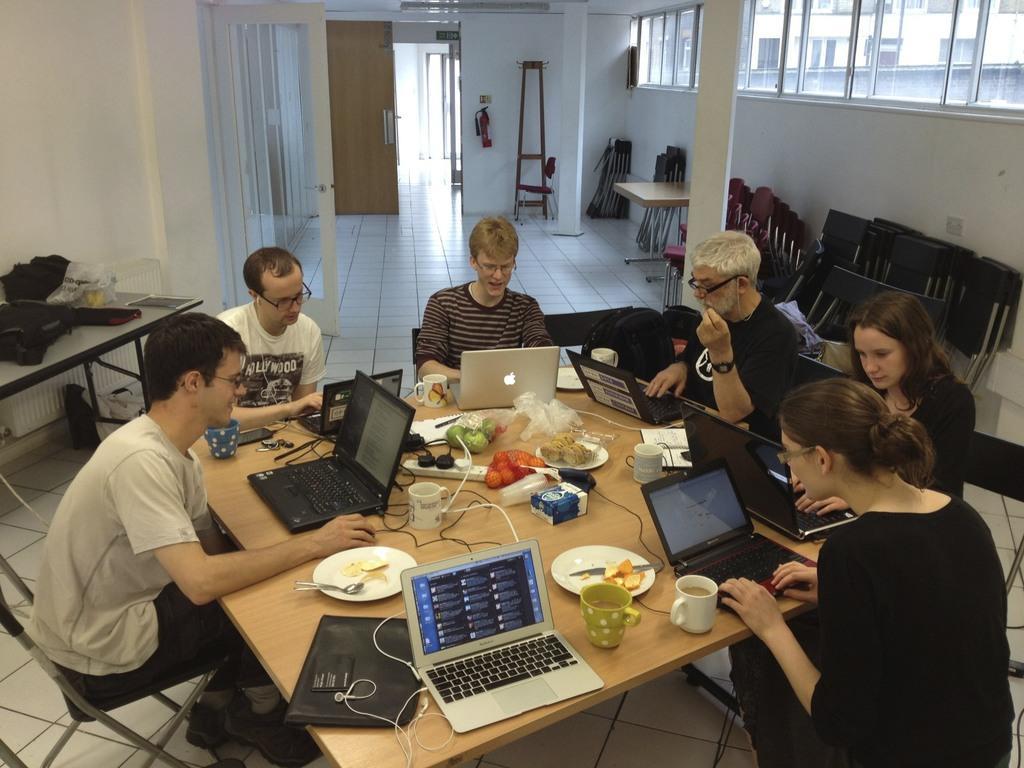Describe this image in one or two sentences. This image is clicked in a room. There is a door on the top. There are tables and chairs, people are sitting in chairs. On the table there are cups, laptops, plates, eatables, spoons, covers, fruits. 